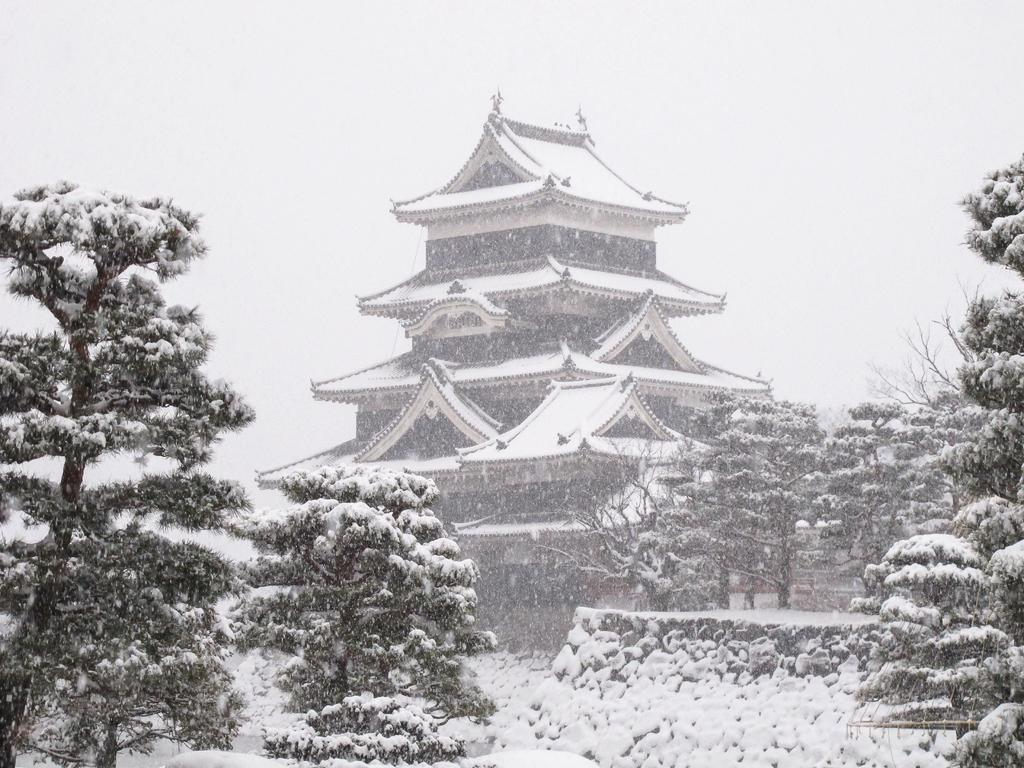What is the color scheme of the image? The image is black and white. What can be seen in the center of the image? There are trees, a building, a wall, a roof, and snow in the center of the image. What is visible in the background of the image? The sky and clouds are visible in the background of the image. What type of patch is sewn onto the building in the image? There is no patch visible on the building in the image. What belief system is represented by the clouds in the image? The clouds in the image do not represent any belief system; they are simply a natural weather phenomenon. 